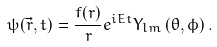Convert formula to latex. <formula><loc_0><loc_0><loc_500><loc_500>\psi ( \vec { r } , t ) = \frac { f ( r ) } { r } e ^ { i E t } Y _ { l m } \left ( \theta , \phi \right ) .</formula> 